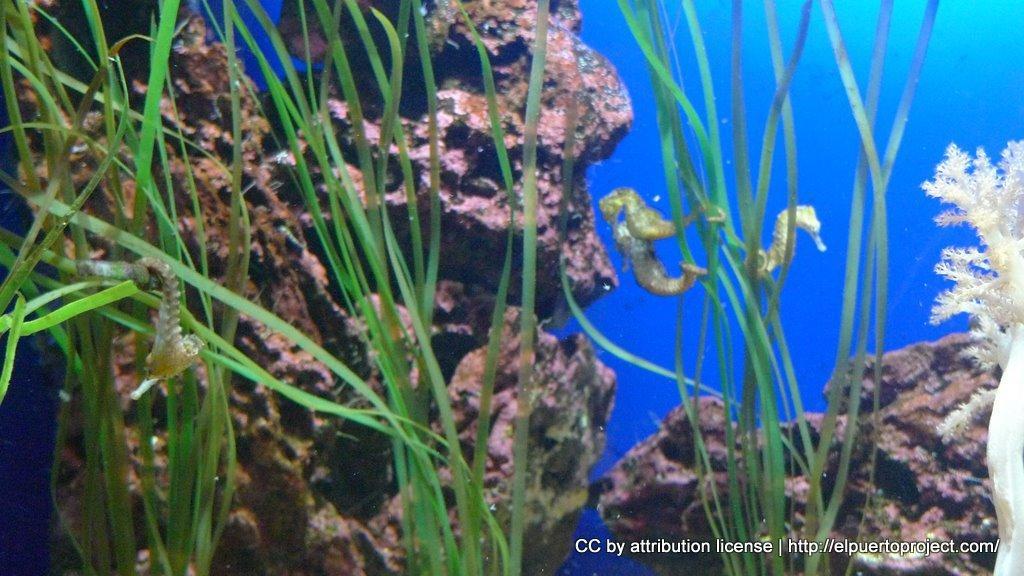Please provide a concise description of this image. In this image we can see some seahorses which are under water and there are some water-plants, stones. 